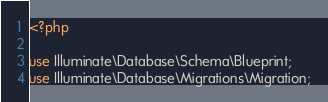Convert code to text. <code><loc_0><loc_0><loc_500><loc_500><_PHP_><?php

use Illuminate\Database\Schema\Blueprint;
use Illuminate\Database\Migrations\Migration;
</code> 